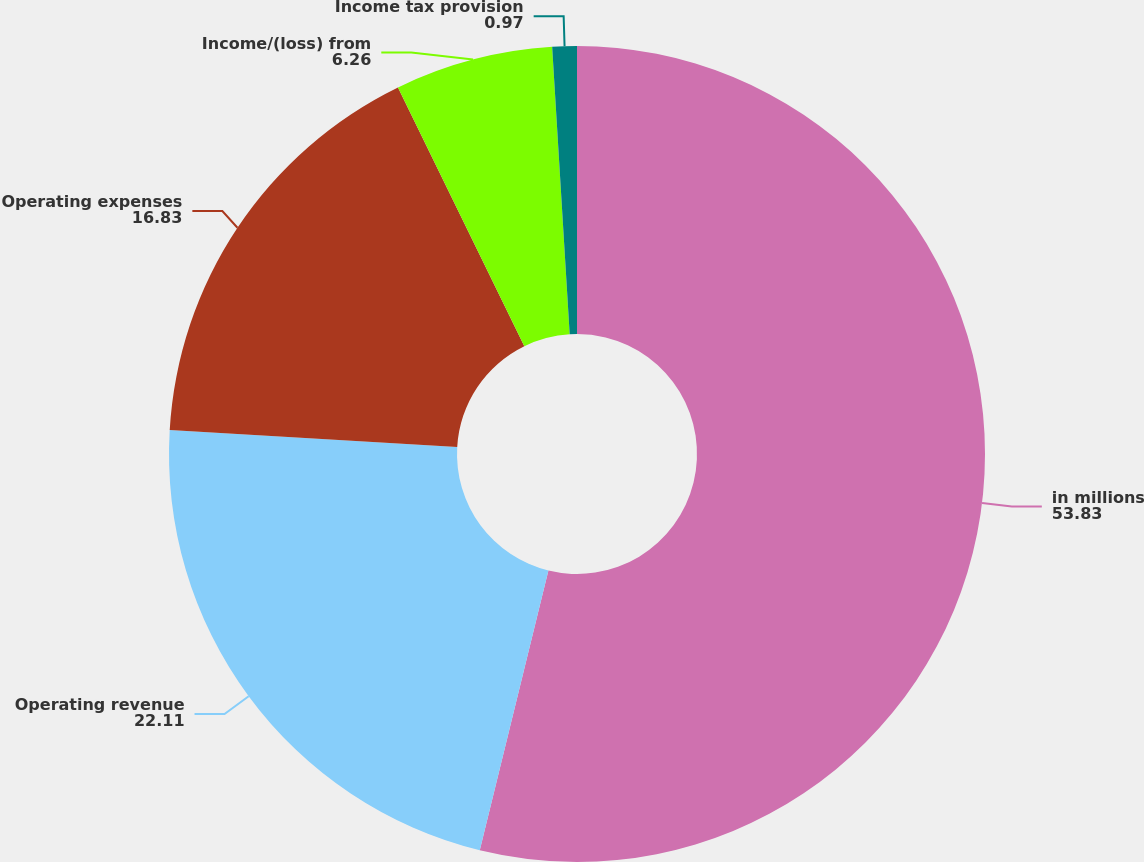Convert chart. <chart><loc_0><loc_0><loc_500><loc_500><pie_chart><fcel>in millions<fcel>Operating revenue<fcel>Operating expenses<fcel>Income/(loss) from<fcel>Income tax provision<nl><fcel>53.83%<fcel>22.11%<fcel>16.83%<fcel>6.26%<fcel>0.97%<nl></chart> 